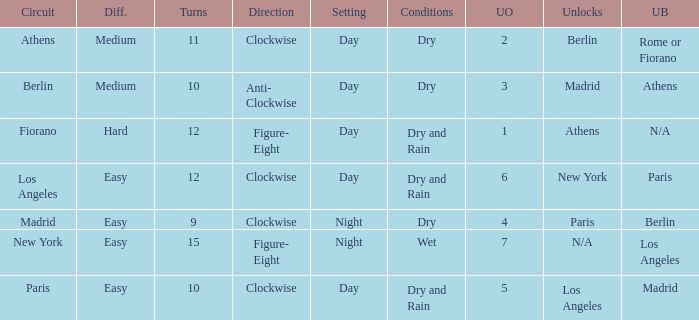How many instances is the unlocked n/a? 1.0. 